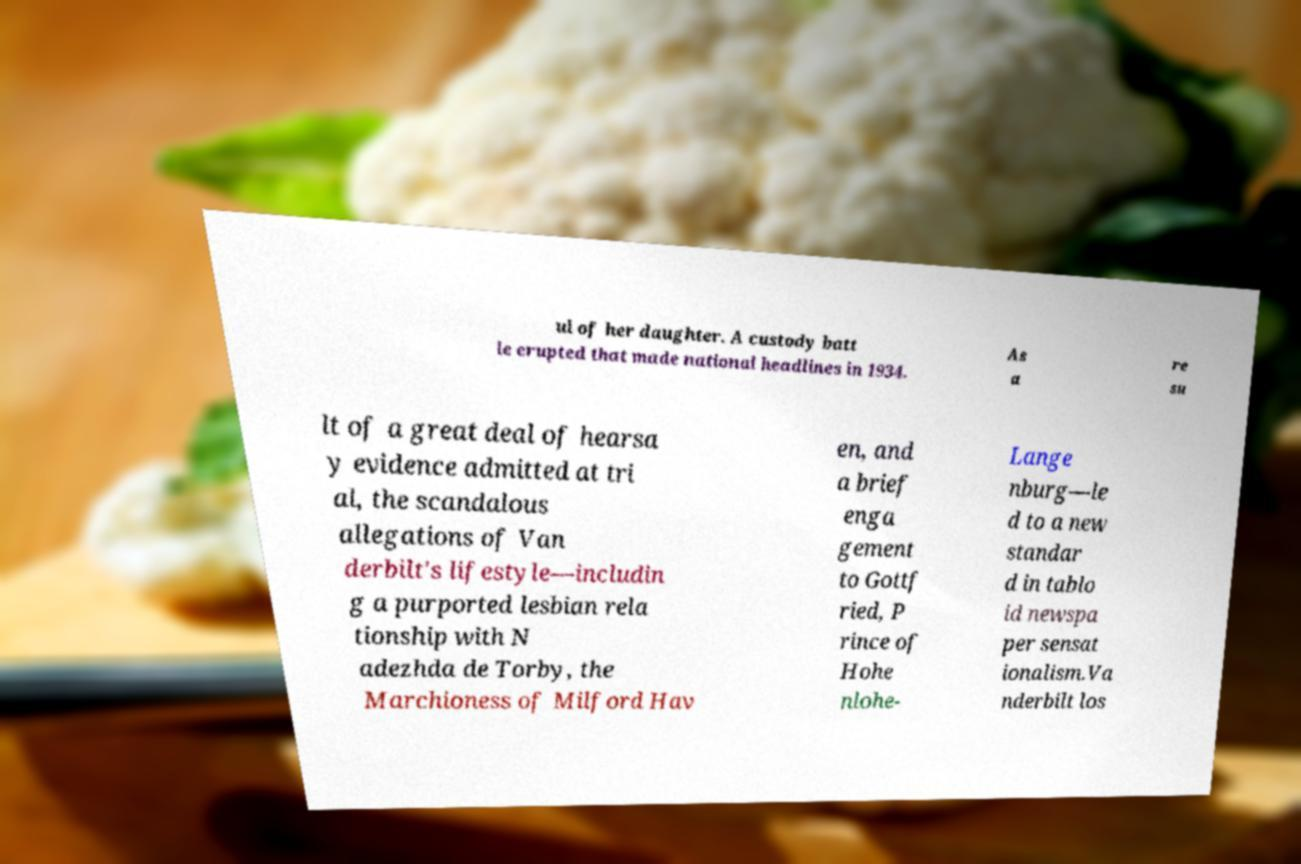Please read and relay the text visible in this image. What does it say? ul of her daughter. A custody batt le erupted that made national headlines in 1934. As a re su lt of a great deal of hearsa y evidence admitted at tri al, the scandalous allegations of Van derbilt's lifestyle—includin g a purported lesbian rela tionship with N adezhda de Torby, the Marchioness of Milford Hav en, and a brief enga gement to Gottf ried, P rince of Hohe nlohe- Lange nburg—le d to a new standar d in tablo id newspa per sensat ionalism.Va nderbilt los 